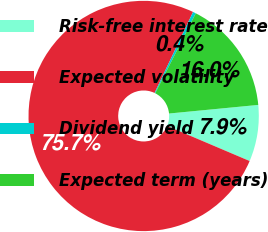Convert chart. <chart><loc_0><loc_0><loc_500><loc_500><pie_chart><fcel>Risk-free interest rate<fcel>Expected volatility<fcel>Dividend yield<fcel>Expected term (years)<nl><fcel>7.93%<fcel>75.66%<fcel>0.42%<fcel>15.99%<nl></chart> 